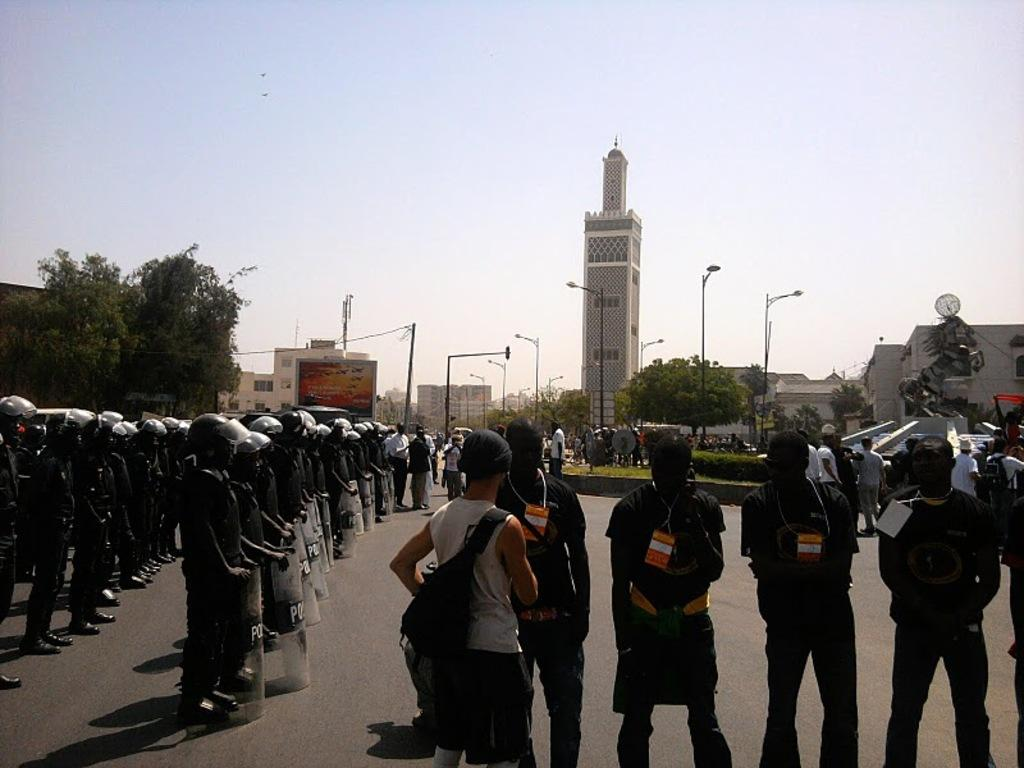What are the people in the image doing? The people in the image are standing on the road. What can be seen in the distance behind the people? There are buildings and trees visible in the background of the image. What type of question is being asked by the person in the image? There is no person asking a question in the image; the people are standing on the road. What invention is being used by the person in the image? There is no person using an invention in the image; the people are standing on the road. 